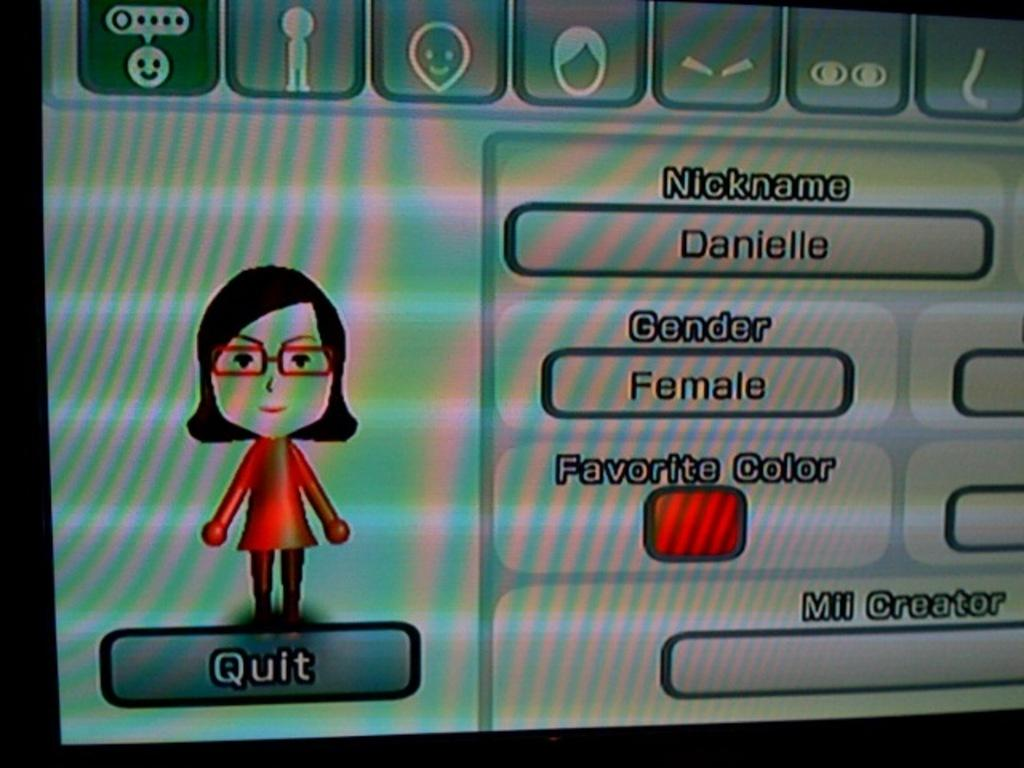What is the main object in the image? There is a monitor screen in the image. What can be seen on the monitor screen? A person is visible on the monitor screen. Are there any words or phrases on the monitor screen? Yes, there is text written on the monitor screen. What type of quill is being used to write on the monitor screen? There is no quill present in the image, as the text on the monitor screen is likely typed or displayed electronically. 